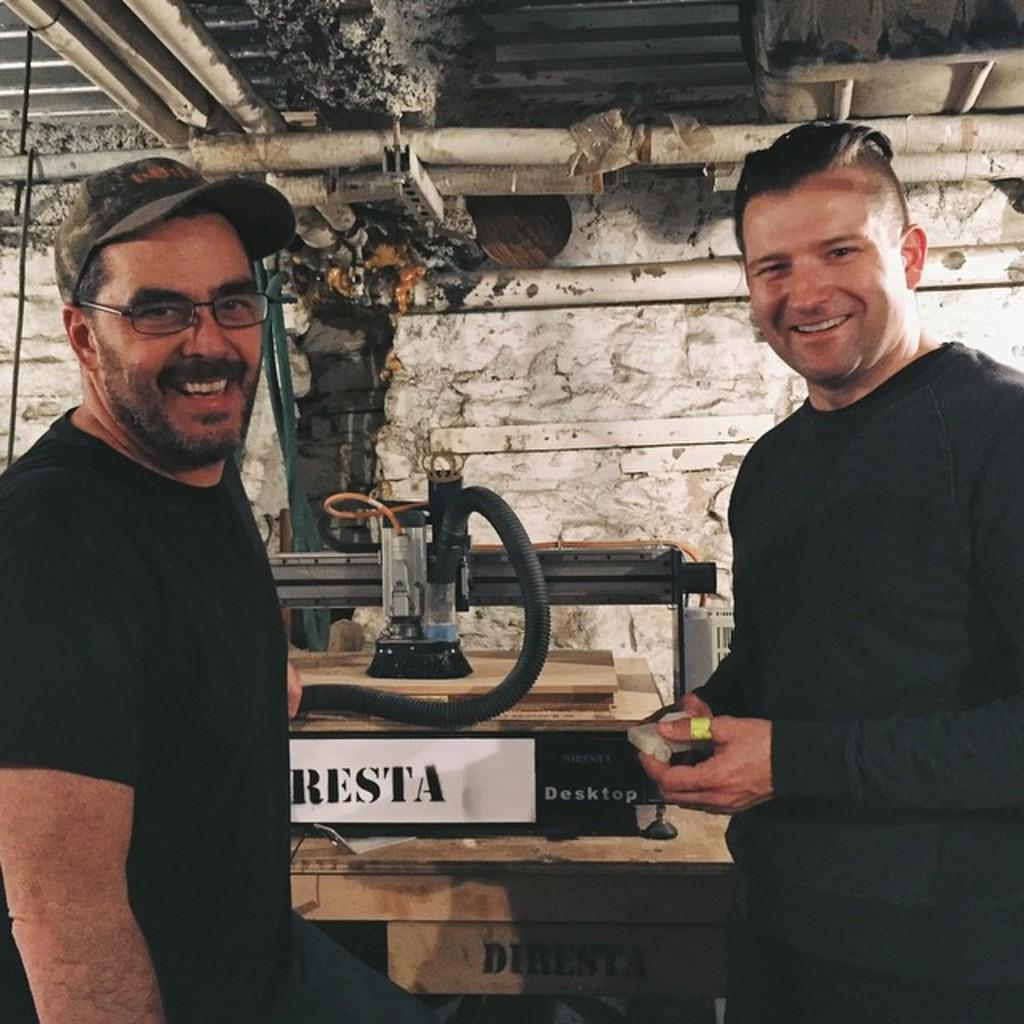How many people are in the image? There are two persons in the image. What are the persons wearing? The persons are wearing clothes. What can be seen on the wooden sheets in the image? There is a machine on wooden sheets. What is located at the bottom of the image? There is a table at the bottom of the image. What is visible at the top of the image? There are pipes at the top of the image. What type of harmony is being played by the police in the image? There is no police or music present in the image; it features two persons, a machine on wooden sheets, a table, and pipes. 